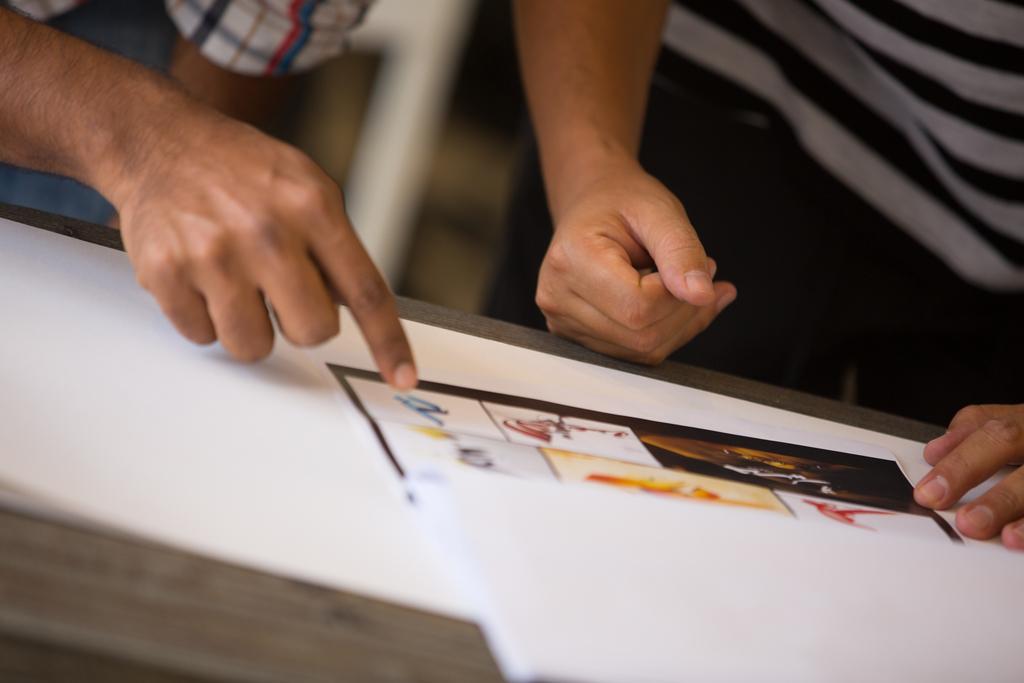Can you describe this image briefly? This image consists of two persons standing. In the front, there is a table on which there are papers. The background is blurred. 